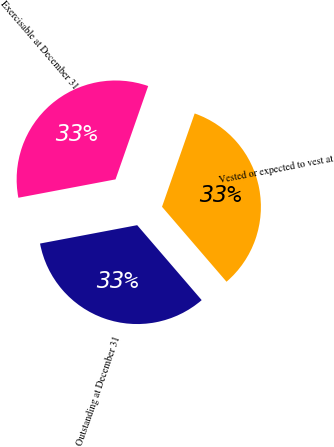Convert chart. <chart><loc_0><loc_0><loc_500><loc_500><pie_chart><fcel>Outstanding at December 31<fcel>Vested or expected to vest at<fcel>Exercisable at December 31<nl><fcel>33.33%<fcel>33.33%<fcel>33.33%<nl></chart> 